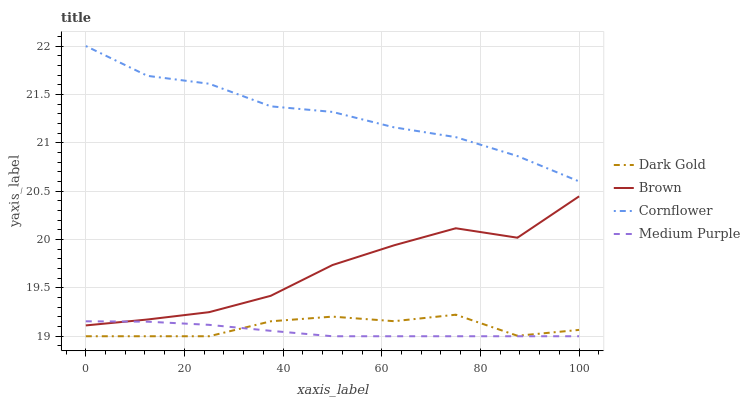Does Medium Purple have the minimum area under the curve?
Answer yes or no. Yes. Does Cornflower have the maximum area under the curve?
Answer yes or no. Yes. Does Brown have the minimum area under the curve?
Answer yes or no. No. Does Brown have the maximum area under the curve?
Answer yes or no. No. Is Medium Purple the smoothest?
Answer yes or no. Yes. Is Brown the roughest?
Answer yes or no. Yes. Is Cornflower the smoothest?
Answer yes or no. No. Is Cornflower the roughest?
Answer yes or no. No. Does Brown have the lowest value?
Answer yes or no. No. Does Cornflower have the highest value?
Answer yes or no. Yes. Does Brown have the highest value?
Answer yes or no. No. Is Medium Purple less than Cornflower?
Answer yes or no. Yes. Is Cornflower greater than Medium Purple?
Answer yes or no. Yes. Does Brown intersect Medium Purple?
Answer yes or no. Yes. Is Brown less than Medium Purple?
Answer yes or no. No. Is Brown greater than Medium Purple?
Answer yes or no. No. Does Medium Purple intersect Cornflower?
Answer yes or no. No. 